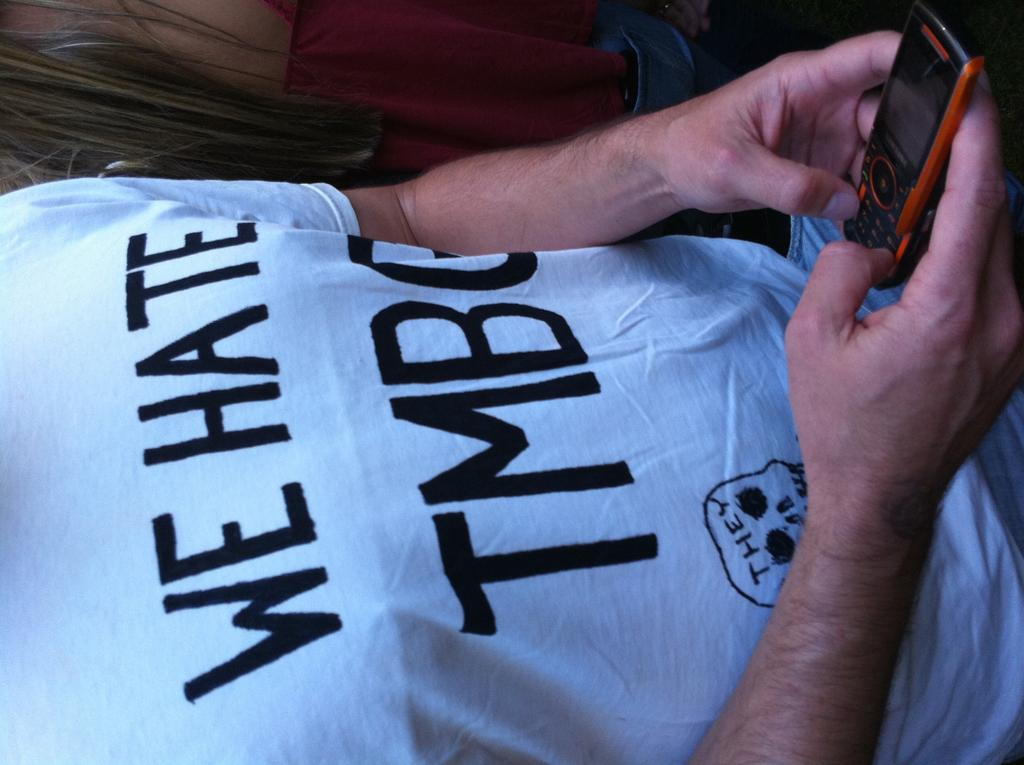<image>
Present a compact description of the photo's key features. a man wearing a white shirt that says 'we hate tmbg' 